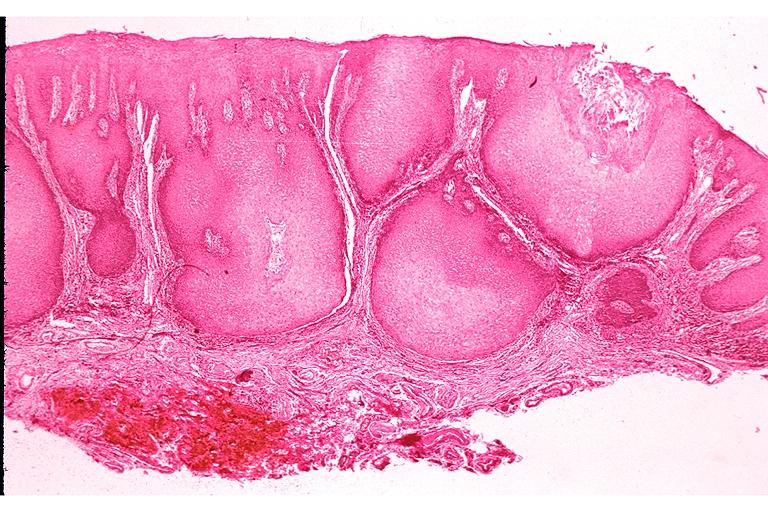what does this image show?
Answer the question using a single word or phrase. Verrucous carcinoma 